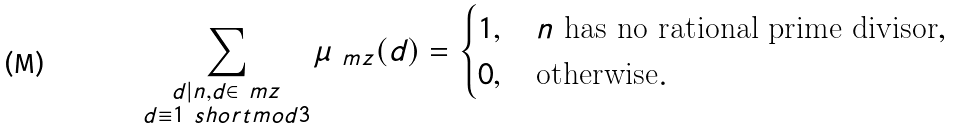<formula> <loc_0><loc_0><loc_500><loc_500>\sum _ { \substack { d | n , d \in \ m z \\ d \equiv 1 \ s h o r t m o d { 3 } } } \mu _ { \ m z } ( d ) = \begin{cases} 1 , \quad \text {$n$ has no rational prime divisor} , \\ 0 , \quad \text {otherwise} . \end{cases}</formula> 